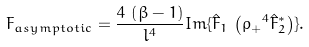Convert formula to latex. <formula><loc_0><loc_0><loc_500><loc_500>F _ { a s y m p t o t i c } = \frac { 4 \, \left ( \beta - 1 \right ) } { l ^ { 4 } } I m \{ \hat { F } _ { 1 } \, \left ( { \rho _ { + } } ^ { 4 } \hat { F } _ { 2 } ^ { * } \right ) \} .</formula> 